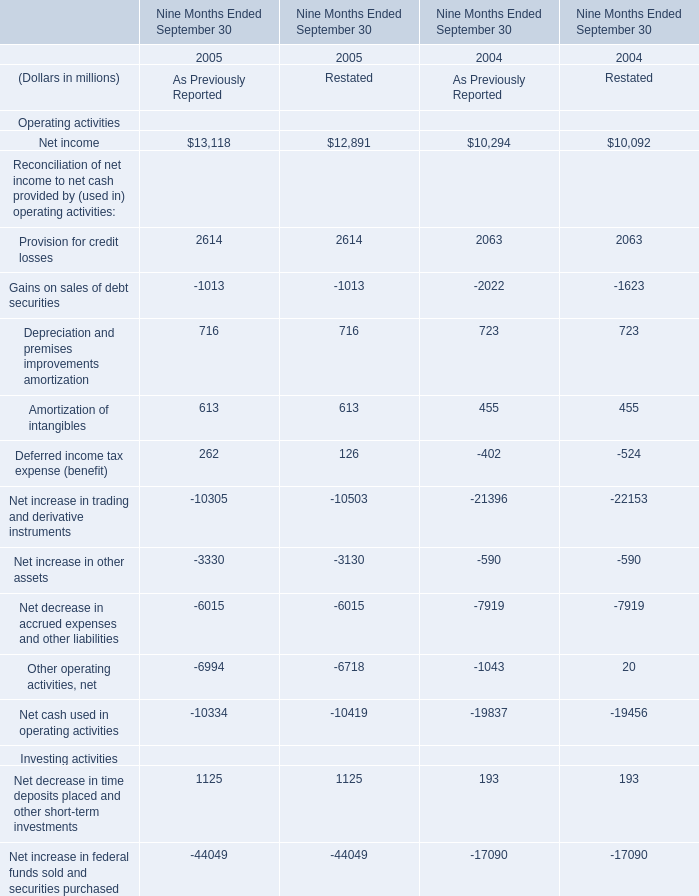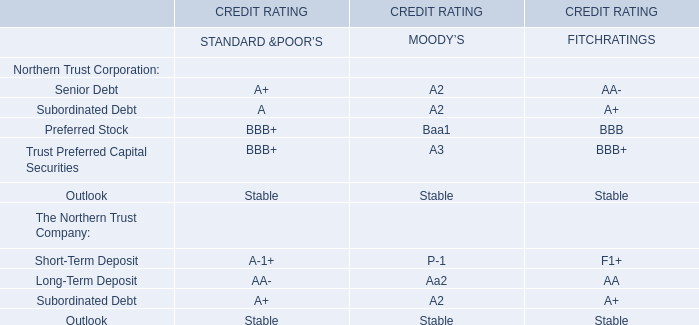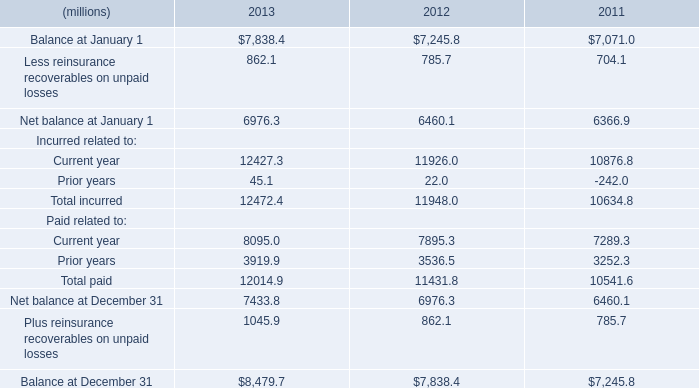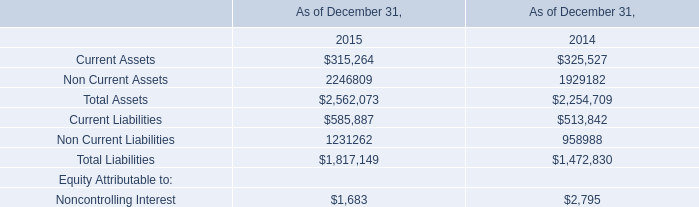What's the average of Amortization of intangibles and Deferred income tax expense (benefit) in 2005? (in millon) 
Computations: ((((613 + 613) + 262) + 126) / 4)
Answer: 403.5. 